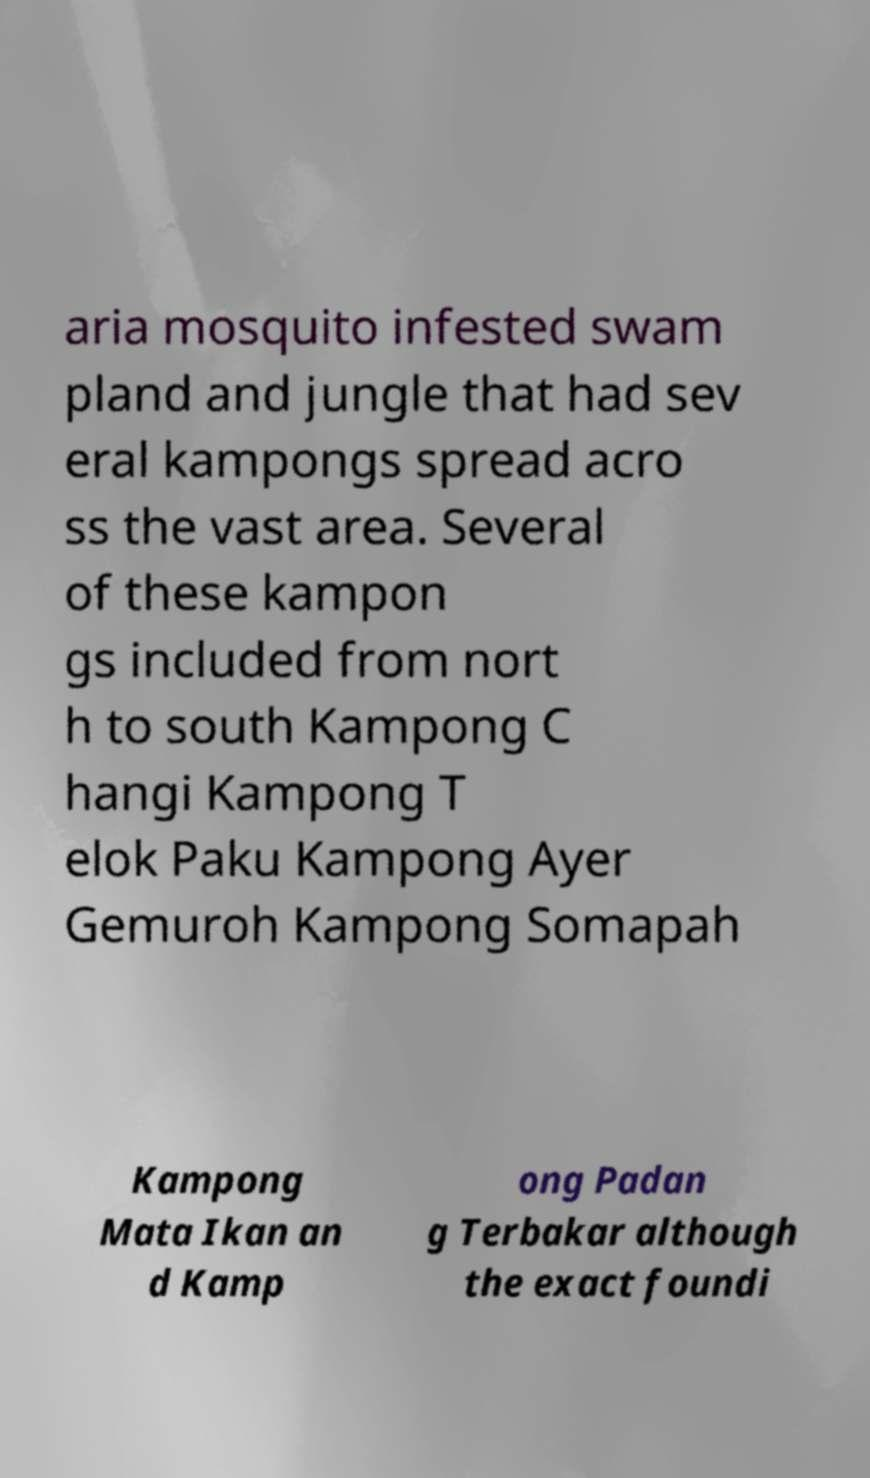Can you accurately transcribe the text from the provided image for me? aria mosquito infested swam pland and jungle that had sev eral kampongs spread acro ss the vast area. Several of these kampon gs included from nort h to south Kampong C hangi Kampong T elok Paku Kampong Ayer Gemuroh Kampong Somapah Kampong Mata Ikan an d Kamp ong Padan g Terbakar although the exact foundi 